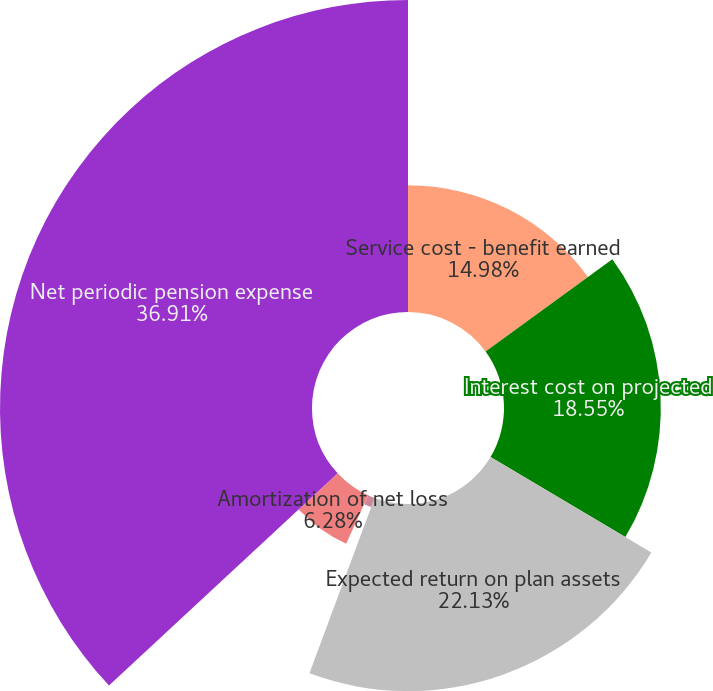<chart> <loc_0><loc_0><loc_500><loc_500><pie_chart><fcel>Service cost - benefit earned<fcel>Interest cost on projected<fcel>Expected return on plan assets<fcel>Amortization of prior service<fcel>Amortization of net loss<fcel>Net periodic pension expense<nl><fcel>14.98%<fcel>18.55%<fcel>22.13%<fcel>1.15%<fcel>6.28%<fcel>36.91%<nl></chart> 